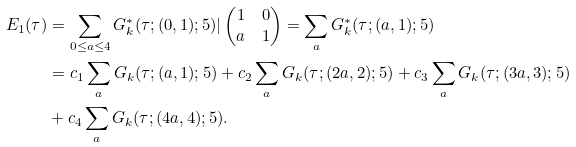<formula> <loc_0><loc_0><loc_500><loc_500>E _ { 1 } ( \tau ) & = \sum _ { 0 \leq a \leq 4 } G ^ { * } _ { k } ( \tau ; ( 0 , 1 ) ; 5 ) | \left ( \begin{matrix} 1 & 0 \\ a & 1 \end{matrix} \right ) = \sum _ { a } G ^ { * } _ { k } ( \tau ; ( a , 1 ) ; 5 ) \\ & = c _ { 1 } \sum _ { a } G _ { k } ( \tau ; ( a , 1 ) ; 5 ) + c _ { 2 } \sum _ { a } G _ { k } ( \tau ; ( 2 a , 2 ) ; 5 ) + c _ { 3 } \sum _ { a } G _ { k } ( \tau ; ( 3 a , 3 ) ; 5 ) \\ \quad & + c _ { 4 } \sum _ { a } G _ { k } ( \tau ; ( 4 a , 4 ) ; 5 ) .</formula> 